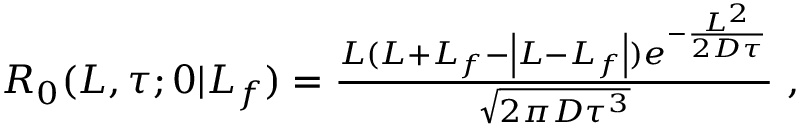<formula> <loc_0><loc_0><loc_500><loc_500>\begin{array} { r } { R _ { 0 } ( L , \tau ; 0 | L _ { f } ) = \frac { L ( L + L _ { f } - \left | L - L _ { f } \right | ) e ^ { - \frac { L ^ { 2 } } { 2 D \tau } } } { \sqrt { 2 \pi D \tau ^ { 3 } } } \ , } \end{array}</formula> 